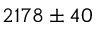<formula> <loc_0><loc_0><loc_500><loc_500>2 1 7 8 \pm 4 0</formula> 